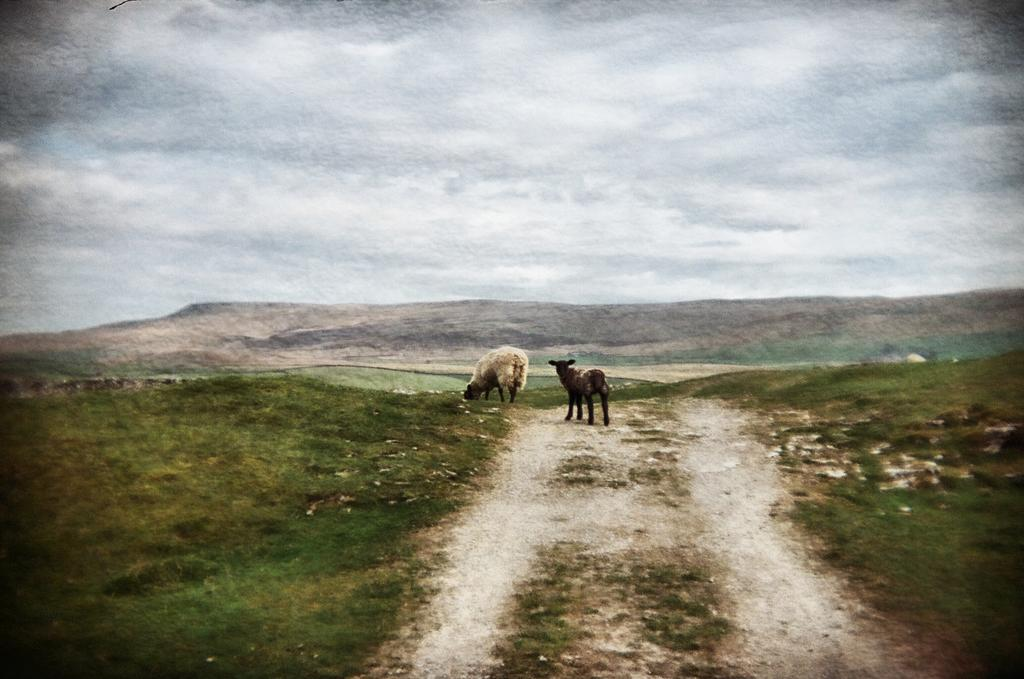What animals are present in the image? There are sheep in the image. What are the sheep doing in the image? One sheep is grazing grass. What type of landscape can be seen in the image? There is a hill in the image. What is the weather like in the image? The sky is cloudy. What type of ornament is hanging from the sheep's neck in the image? There is no ornament hanging from the sheep's neck in the image; the sheep are not adorned with any accessories. 